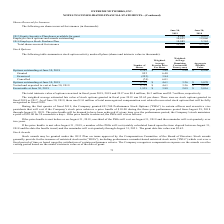From Extreme Networks's financial document, Which years does the table provide information for the company's shares reserved for issuance? The document shows two values: 2019 and 2018. From the document: "2019 2018..." Also, What was the amount of Employee stock options and awards outstanding in 2018? According to the financial document, 12,060 (in thousands). The relevant text states: "loyee stock options and awards outstanding 10,455 12,060..." Also, What was the amount of Total shares reserved for issuance in 2019? According to the financial document, 29,002 (in thousands). The relevant text states: "Total shares reserved for issuance 29,002 27,382..." Also, How many years did 2013 Equity Incentive Plan shares available for grant exceed $5,000 thousand? Counting the relevant items in the document: 2019, 2018, I find 2 instances. The key data points involved are: 2018, 2019. Also, can you calculate: What was the change in the 2014 Employee Stock Purchase Plan between 2018 and 2019? Based on the calculation: 10,085-5,365, the result is 4720 (in thousands). This is based on the information: "2014 Employee Stock Purchase Plan 10,085 5,365 2014 Employee Stock Purchase Plan 10,085 5,365..." The key data points involved are: 10,085, 5,365. Also, can you calculate: What was the percentage change in the Total shares reserved for issuance between 2018 and 2019? To answer this question, I need to perform calculations using the financial data. The calculation is: (29,002-27,382)/27,382, which equals 5.92 (percentage). This is based on the information: "Total shares reserved for issuance 29,002 27,382 Total shares reserved for issuance 29,002 27,382..." The key data points involved are: 27,382, 29,002. 